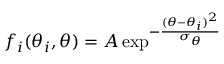<formula> <loc_0><loc_0><loc_500><loc_500>f _ { i } ( \theta _ { i } , \theta ) = A \exp ^ { - \frac { ( \theta - \theta _ { i } ) ^ { 2 } } { \sigma _ { \theta } } }</formula> 